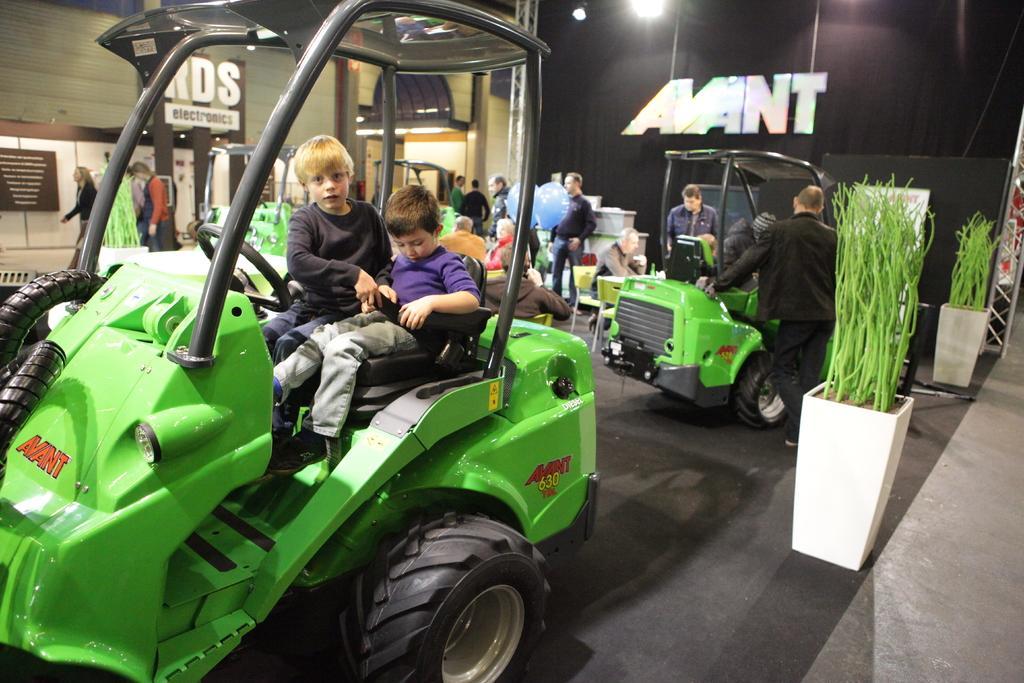Could you give a brief overview of what you see in this image? In this image there are group of persons standing, walking and sitting. In the front there are kids sitting in a car which is green in colour. On the right side there are plants and there is a car. In the background there are some texts written on the wall. 